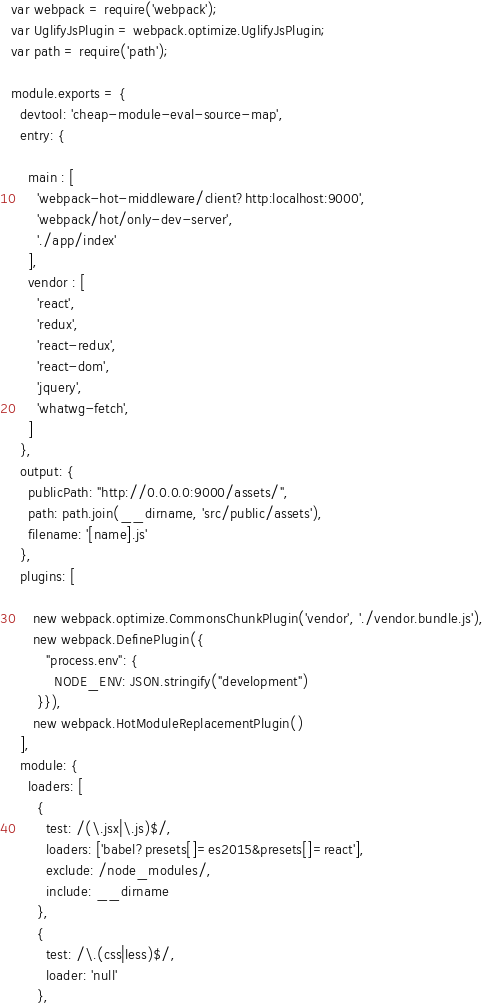<code> <loc_0><loc_0><loc_500><loc_500><_JavaScript_>var webpack = require('webpack');
var UglifyJsPlugin = webpack.optimize.UglifyJsPlugin;
var path = require('path');

module.exports = {
  devtool: 'cheap-module-eval-source-map',
  entry: {
      
    main : [
      'webpack-hot-middleware/client?http:localhost:9000',
      'webpack/hot/only-dev-server',
      './app/index'
    ],
    vendor : [
      'react',
      'redux',
      'react-redux',
      'react-dom',
      'jquery',
      'whatwg-fetch',
    ]
  },
  output: {
    publicPath: "http://0.0.0.0:9000/assets/",
    path: path.join(__dirname, 'src/public/assets'),
    filename: '[name].js'
  },
  plugins: [
    
     new webpack.optimize.CommonsChunkPlugin('vendor', './vendor.bundle.js'),
     new webpack.DefinePlugin({
        "process.env": {
          NODE_ENV: JSON.stringify("development")
      }}),
     new webpack.HotModuleReplacementPlugin()
  ],
  module: {
    loaders: [
      {
        test: /(\.jsx|\.js)$/,
        loaders: ['babel?presets[]=es2015&presets[]=react'],
        exclude: /node_modules/,
        include: __dirname
      },
      {
        test: /\.(css|less)$/,
        loader: 'null'
      },</code> 